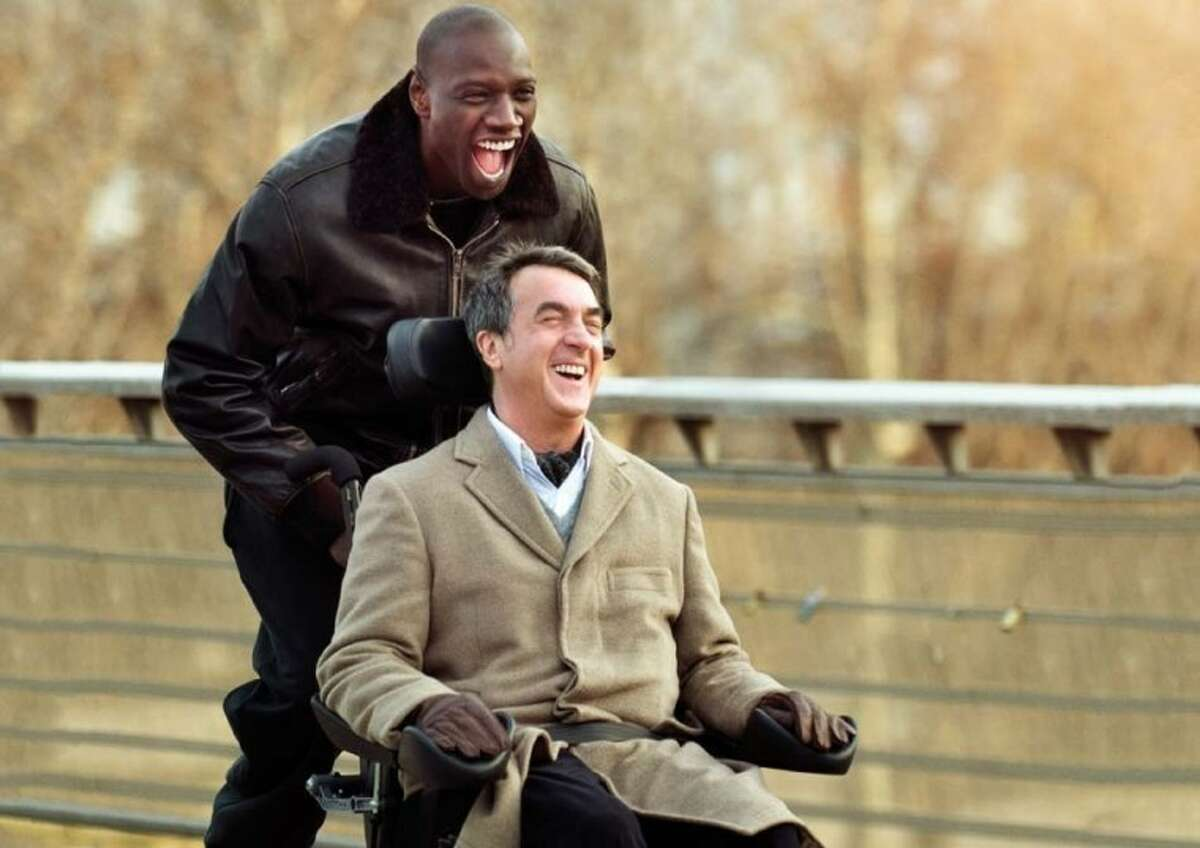Can you elaborate on how the clothing of the characters adds depth to this scene? Certainly! Fran\u00e7ois Cluzet is dressed in a classic, earth-toned coat and scarf, suggesting a refined, comfortable yet somewhat conservative lifestyle, which aligns with his character's affluent background but restrained life due to disability. Omar Sy, in contrast, wears a black leather jacket, signifying his more carefree, resilient, and vigorous approach to life. These contrasting styles highlight the differences in their backgrounds, yet they're united in laughter and joy, reinforcing the film's themes of unity and mutual respect regardless of social divisions. 